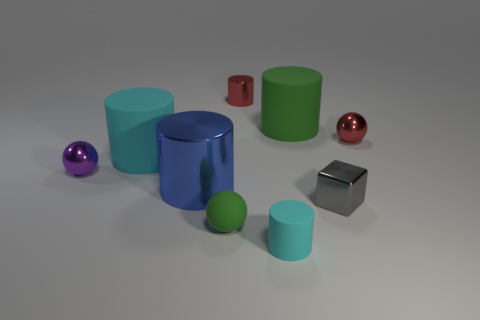Subtract all blue cylinders. How many cylinders are left? 4 Subtract all red cylinders. How many cylinders are left? 4 Subtract all brown cylinders. Subtract all cyan balls. How many cylinders are left? 5 Add 1 tiny matte cylinders. How many objects exist? 10 Subtract all spheres. How many objects are left? 6 Add 3 shiny objects. How many shiny objects exist? 8 Subtract 0 blue spheres. How many objects are left? 9 Subtract all big cylinders. Subtract all small gray spheres. How many objects are left? 6 Add 3 tiny green rubber spheres. How many tiny green rubber spheres are left? 4 